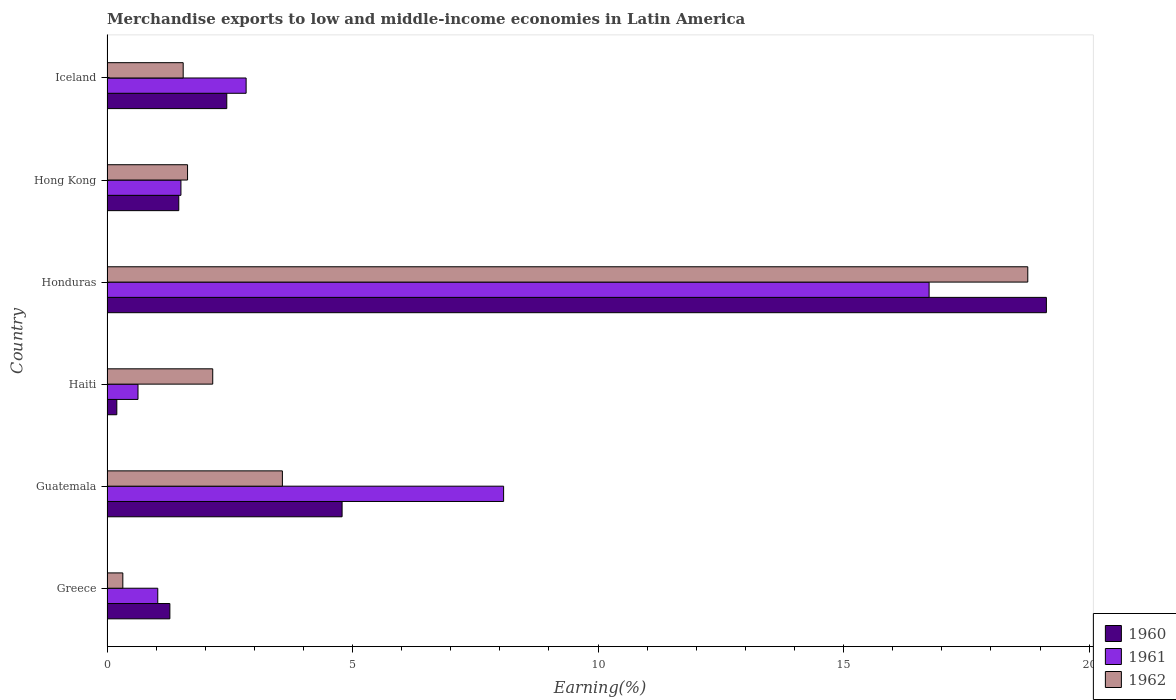How many bars are there on the 2nd tick from the top?
Offer a very short reply. 3. What is the label of the 2nd group of bars from the top?
Make the answer very short. Hong Kong. In how many cases, is the number of bars for a given country not equal to the number of legend labels?
Offer a very short reply. 0. What is the percentage of amount earned from merchandise exports in 1961 in Hong Kong?
Provide a succinct answer. 1.51. Across all countries, what is the maximum percentage of amount earned from merchandise exports in 1961?
Provide a succinct answer. 16.74. Across all countries, what is the minimum percentage of amount earned from merchandise exports in 1960?
Make the answer very short. 0.2. In which country was the percentage of amount earned from merchandise exports in 1960 maximum?
Provide a short and direct response. Honduras. In which country was the percentage of amount earned from merchandise exports in 1961 minimum?
Ensure brevity in your answer.  Haiti. What is the total percentage of amount earned from merchandise exports in 1960 in the graph?
Offer a very short reply. 29.3. What is the difference between the percentage of amount earned from merchandise exports in 1961 in Honduras and that in Iceland?
Give a very brief answer. 13.91. What is the difference between the percentage of amount earned from merchandise exports in 1962 in Iceland and the percentage of amount earned from merchandise exports in 1960 in Haiti?
Make the answer very short. 1.35. What is the average percentage of amount earned from merchandise exports in 1961 per country?
Ensure brevity in your answer.  5.14. What is the difference between the percentage of amount earned from merchandise exports in 1962 and percentage of amount earned from merchandise exports in 1960 in Iceland?
Make the answer very short. -0.89. What is the ratio of the percentage of amount earned from merchandise exports in 1962 in Greece to that in Haiti?
Your response must be concise. 0.15. What is the difference between the highest and the second highest percentage of amount earned from merchandise exports in 1960?
Provide a succinct answer. 14.34. What is the difference between the highest and the lowest percentage of amount earned from merchandise exports in 1962?
Offer a very short reply. 18.43. What does the 2nd bar from the top in Haiti represents?
Your response must be concise. 1961. Is it the case that in every country, the sum of the percentage of amount earned from merchandise exports in 1960 and percentage of amount earned from merchandise exports in 1961 is greater than the percentage of amount earned from merchandise exports in 1962?
Provide a succinct answer. No. Does the graph contain grids?
Provide a succinct answer. No. How many legend labels are there?
Give a very brief answer. 3. How are the legend labels stacked?
Your answer should be compact. Vertical. What is the title of the graph?
Provide a short and direct response. Merchandise exports to low and middle-income economies in Latin America. What is the label or title of the X-axis?
Keep it short and to the point. Earning(%). What is the label or title of the Y-axis?
Ensure brevity in your answer.  Country. What is the Earning(%) in 1960 in Greece?
Offer a very short reply. 1.28. What is the Earning(%) of 1961 in Greece?
Give a very brief answer. 1.03. What is the Earning(%) of 1962 in Greece?
Ensure brevity in your answer.  0.32. What is the Earning(%) in 1960 in Guatemala?
Give a very brief answer. 4.79. What is the Earning(%) of 1961 in Guatemala?
Your response must be concise. 8.08. What is the Earning(%) of 1962 in Guatemala?
Your answer should be compact. 3.57. What is the Earning(%) of 1960 in Haiti?
Offer a very short reply. 0.2. What is the Earning(%) in 1961 in Haiti?
Your answer should be very brief. 0.63. What is the Earning(%) in 1962 in Haiti?
Offer a very short reply. 2.15. What is the Earning(%) of 1960 in Honduras?
Provide a succinct answer. 19.13. What is the Earning(%) in 1961 in Honduras?
Offer a terse response. 16.74. What is the Earning(%) of 1962 in Honduras?
Your response must be concise. 18.75. What is the Earning(%) of 1960 in Hong Kong?
Ensure brevity in your answer.  1.46. What is the Earning(%) in 1961 in Hong Kong?
Your answer should be very brief. 1.51. What is the Earning(%) in 1962 in Hong Kong?
Offer a very short reply. 1.64. What is the Earning(%) in 1960 in Iceland?
Ensure brevity in your answer.  2.44. What is the Earning(%) of 1961 in Iceland?
Your answer should be compact. 2.83. What is the Earning(%) of 1962 in Iceland?
Give a very brief answer. 1.55. Across all countries, what is the maximum Earning(%) in 1960?
Make the answer very short. 19.13. Across all countries, what is the maximum Earning(%) of 1961?
Your response must be concise. 16.74. Across all countries, what is the maximum Earning(%) of 1962?
Your answer should be very brief. 18.75. Across all countries, what is the minimum Earning(%) of 1960?
Give a very brief answer. 0.2. Across all countries, what is the minimum Earning(%) in 1961?
Give a very brief answer. 0.63. Across all countries, what is the minimum Earning(%) in 1962?
Your answer should be compact. 0.32. What is the total Earning(%) of 1960 in the graph?
Your answer should be compact. 29.3. What is the total Earning(%) of 1961 in the graph?
Offer a very short reply. 30.82. What is the total Earning(%) of 1962 in the graph?
Provide a succinct answer. 27.99. What is the difference between the Earning(%) of 1960 in Greece and that in Guatemala?
Keep it short and to the point. -3.51. What is the difference between the Earning(%) in 1961 in Greece and that in Guatemala?
Give a very brief answer. -7.04. What is the difference between the Earning(%) of 1962 in Greece and that in Guatemala?
Provide a short and direct response. -3.25. What is the difference between the Earning(%) in 1960 in Greece and that in Haiti?
Offer a terse response. 1.08. What is the difference between the Earning(%) of 1961 in Greece and that in Haiti?
Ensure brevity in your answer.  0.4. What is the difference between the Earning(%) of 1962 in Greece and that in Haiti?
Keep it short and to the point. -1.83. What is the difference between the Earning(%) in 1960 in Greece and that in Honduras?
Offer a very short reply. -17.85. What is the difference between the Earning(%) of 1961 in Greece and that in Honduras?
Offer a terse response. -15.71. What is the difference between the Earning(%) of 1962 in Greece and that in Honduras?
Provide a succinct answer. -18.43. What is the difference between the Earning(%) in 1960 in Greece and that in Hong Kong?
Offer a very short reply. -0.18. What is the difference between the Earning(%) in 1961 in Greece and that in Hong Kong?
Ensure brevity in your answer.  -0.47. What is the difference between the Earning(%) in 1962 in Greece and that in Hong Kong?
Provide a succinct answer. -1.32. What is the difference between the Earning(%) in 1960 in Greece and that in Iceland?
Your response must be concise. -1.16. What is the difference between the Earning(%) in 1961 in Greece and that in Iceland?
Offer a very short reply. -1.8. What is the difference between the Earning(%) of 1962 in Greece and that in Iceland?
Keep it short and to the point. -1.23. What is the difference between the Earning(%) in 1960 in Guatemala and that in Haiti?
Your answer should be very brief. 4.59. What is the difference between the Earning(%) of 1961 in Guatemala and that in Haiti?
Provide a short and direct response. 7.45. What is the difference between the Earning(%) in 1962 in Guatemala and that in Haiti?
Your answer should be very brief. 1.42. What is the difference between the Earning(%) in 1960 in Guatemala and that in Honduras?
Your response must be concise. -14.34. What is the difference between the Earning(%) of 1961 in Guatemala and that in Honduras?
Your response must be concise. -8.66. What is the difference between the Earning(%) in 1962 in Guatemala and that in Honduras?
Keep it short and to the point. -15.18. What is the difference between the Earning(%) of 1960 in Guatemala and that in Hong Kong?
Your answer should be compact. 3.33. What is the difference between the Earning(%) of 1961 in Guatemala and that in Hong Kong?
Your answer should be very brief. 6.57. What is the difference between the Earning(%) in 1962 in Guatemala and that in Hong Kong?
Your answer should be very brief. 1.93. What is the difference between the Earning(%) of 1960 in Guatemala and that in Iceland?
Your answer should be compact. 2.35. What is the difference between the Earning(%) in 1961 in Guatemala and that in Iceland?
Offer a terse response. 5.24. What is the difference between the Earning(%) of 1962 in Guatemala and that in Iceland?
Your answer should be very brief. 2.02. What is the difference between the Earning(%) in 1960 in Haiti and that in Honduras?
Offer a very short reply. -18.93. What is the difference between the Earning(%) in 1961 in Haiti and that in Honduras?
Offer a terse response. -16.11. What is the difference between the Earning(%) of 1962 in Haiti and that in Honduras?
Offer a very short reply. -16.6. What is the difference between the Earning(%) of 1960 in Haiti and that in Hong Kong?
Ensure brevity in your answer.  -1.26. What is the difference between the Earning(%) in 1961 in Haiti and that in Hong Kong?
Offer a terse response. -0.87. What is the difference between the Earning(%) in 1962 in Haiti and that in Hong Kong?
Your answer should be very brief. 0.51. What is the difference between the Earning(%) of 1960 in Haiti and that in Iceland?
Make the answer very short. -2.24. What is the difference between the Earning(%) in 1961 in Haiti and that in Iceland?
Give a very brief answer. -2.2. What is the difference between the Earning(%) in 1962 in Haiti and that in Iceland?
Provide a succinct answer. 0.6. What is the difference between the Earning(%) in 1960 in Honduras and that in Hong Kong?
Your answer should be compact. 17.67. What is the difference between the Earning(%) of 1961 in Honduras and that in Hong Kong?
Your response must be concise. 15.24. What is the difference between the Earning(%) of 1962 in Honduras and that in Hong Kong?
Provide a short and direct response. 17.11. What is the difference between the Earning(%) of 1960 in Honduras and that in Iceland?
Your response must be concise. 16.69. What is the difference between the Earning(%) of 1961 in Honduras and that in Iceland?
Your response must be concise. 13.91. What is the difference between the Earning(%) in 1962 in Honduras and that in Iceland?
Make the answer very short. 17.2. What is the difference between the Earning(%) in 1960 in Hong Kong and that in Iceland?
Your response must be concise. -0.98. What is the difference between the Earning(%) of 1961 in Hong Kong and that in Iceland?
Offer a terse response. -1.33. What is the difference between the Earning(%) of 1962 in Hong Kong and that in Iceland?
Provide a succinct answer. 0.09. What is the difference between the Earning(%) in 1960 in Greece and the Earning(%) in 1961 in Guatemala?
Your answer should be compact. -6.8. What is the difference between the Earning(%) of 1960 in Greece and the Earning(%) of 1962 in Guatemala?
Give a very brief answer. -2.29. What is the difference between the Earning(%) of 1961 in Greece and the Earning(%) of 1962 in Guatemala?
Provide a succinct answer. -2.54. What is the difference between the Earning(%) of 1960 in Greece and the Earning(%) of 1961 in Haiti?
Give a very brief answer. 0.65. What is the difference between the Earning(%) in 1960 in Greece and the Earning(%) in 1962 in Haiti?
Provide a succinct answer. -0.87. What is the difference between the Earning(%) in 1961 in Greece and the Earning(%) in 1962 in Haiti?
Your answer should be compact. -1.12. What is the difference between the Earning(%) in 1960 in Greece and the Earning(%) in 1961 in Honduras?
Your response must be concise. -15.46. What is the difference between the Earning(%) of 1960 in Greece and the Earning(%) of 1962 in Honduras?
Your answer should be compact. -17.47. What is the difference between the Earning(%) in 1961 in Greece and the Earning(%) in 1962 in Honduras?
Your response must be concise. -17.72. What is the difference between the Earning(%) of 1960 in Greece and the Earning(%) of 1961 in Hong Kong?
Your response must be concise. -0.23. What is the difference between the Earning(%) in 1960 in Greece and the Earning(%) in 1962 in Hong Kong?
Your answer should be very brief. -0.36. What is the difference between the Earning(%) in 1961 in Greece and the Earning(%) in 1962 in Hong Kong?
Your response must be concise. -0.61. What is the difference between the Earning(%) in 1960 in Greece and the Earning(%) in 1961 in Iceland?
Your response must be concise. -1.55. What is the difference between the Earning(%) in 1960 in Greece and the Earning(%) in 1962 in Iceland?
Keep it short and to the point. -0.27. What is the difference between the Earning(%) in 1961 in Greece and the Earning(%) in 1962 in Iceland?
Ensure brevity in your answer.  -0.52. What is the difference between the Earning(%) in 1960 in Guatemala and the Earning(%) in 1961 in Haiti?
Your answer should be compact. 4.16. What is the difference between the Earning(%) of 1960 in Guatemala and the Earning(%) of 1962 in Haiti?
Provide a short and direct response. 2.63. What is the difference between the Earning(%) in 1961 in Guatemala and the Earning(%) in 1962 in Haiti?
Your answer should be very brief. 5.92. What is the difference between the Earning(%) in 1960 in Guatemala and the Earning(%) in 1961 in Honduras?
Keep it short and to the point. -11.95. What is the difference between the Earning(%) in 1960 in Guatemala and the Earning(%) in 1962 in Honduras?
Your response must be concise. -13.96. What is the difference between the Earning(%) of 1961 in Guatemala and the Earning(%) of 1962 in Honduras?
Ensure brevity in your answer.  -10.67. What is the difference between the Earning(%) of 1960 in Guatemala and the Earning(%) of 1961 in Hong Kong?
Ensure brevity in your answer.  3.28. What is the difference between the Earning(%) of 1960 in Guatemala and the Earning(%) of 1962 in Hong Kong?
Offer a very short reply. 3.15. What is the difference between the Earning(%) in 1961 in Guatemala and the Earning(%) in 1962 in Hong Kong?
Your answer should be very brief. 6.44. What is the difference between the Earning(%) of 1960 in Guatemala and the Earning(%) of 1961 in Iceland?
Keep it short and to the point. 1.95. What is the difference between the Earning(%) in 1960 in Guatemala and the Earning(%) in 1962 in Iceland?
Provide a succinct answer. 3.24. What is the difference between the Earning(%) of 1961 in Guatemala and the Earning(%) of 1962 in Iceland?
Keep it short and to the point. 6.52. What is the difference between the Earning(%) of 1960 in Haiti and the Earning(%) of 1961 in Honduras?
Ensure brevity in your answer.  -16.54. What is the difference between the Earning(%) in 1960 in Haiti and the Earning(%) in 1962 in Honduras?
Make the answer very short. -18.55. What is the difference between the Earning(%) in 1961 in Haiti and the Earning(%) in 1962 in Honduras?
Give a very brief answer. -18.12. What is the difference between the Earning(%) in 1960 in Haiti and the Earning(%) in 1961 in Hong Kong?
Offer a very short reply. -1.31. What is the difference between the Earning(%) in 1960 in Haiti and the Earning(%) in 1962 in Hong Kong?
Your response must be concise. -1.44. What is the difference between the Earning(%) in 1961 in Haiti and the Earning(%) in 1962 in Hong Kong?
Your response must be concise. -1.01. What is the difference between the Earning(%) of 1960 in Haiti and the Earning(%) of 1961 in Iceland?
Ensure brevity in your answer.  -2.63. What is the difference between the Earning(%) of 1960 in Haiti and the Earning(%) of 1962 in Iceland?
Your answer should be very brief. -1.35. What is the difference between the Earning(%) in 1961 in Haiti and the Earning(%) in 1962 in Iceland?
Ensure brevity in your answer.  -0.92. What is the difference between the Earning(%) in 1960 in Honduras and the Earning(%) in 1961 in Hong Kong?
Offer a very short reply. 17.62. What is the difference between the Earning(%) in 1960 in Honduras and the Earning(%) in 1962 in Hong Kong?
Ensure brevity in your answer.  17.49. What is the difference between the Earning(%) of 1961 in Honduras and the Earning(%) of 1962 in Hong Kong?
Provide a succinct answer. 15.1. What is the difference between the Earning(%) in 1960 in Honduras and the Earning(%) in 1961 in Iceland?
Give a very brief answer. 16.3. What is the difference between the Earning(%) in 1960 in Honduras and the Earning(%) in 1962 in Iceland?
Provide a succinct answer. 17.58. What is the difference between the Earning(%) of 1961 in Honduras and the Earning(%) of 1962 in Iceland?
Provide a short and direct response. 15.19. What is the difference between the Earning(%) of 1960 in Hong Kong and the Earning(%) of 1961 in Iceland?
Your answer should be compact. -1.37. What is the difference between the Earning(%) in 1960 in Hong Kong and the Earning(%) in 1962 in Iceland?
Offer a terse response. -0.09. What is the difference between the Earning(%) of 1961 in Hong Kong and the Earning(%) of 1962 in Iceland?
Your response must be concise. -0.05. What is the average Earning(%) in 1960 per country?
Offer a very short reply. 4.88. What is the average Earning(%) in 1961 per country?
Your answer should be very brief. 5.14. What is the average Earning(%) of 1962 per country?
Ensure brevity in your answer.  4.66. What is the difference between the Earning(%) in 1960 and Earning(%) in 1961 in Greece?
Keep it short and to the point. 0.25. What is the difference between the Earning(%) of 1960 and Earning(%) of 1962 in Greece?
Provide a short and direct response. 0.96. What is the difference between the Earning(%) of 1961 and Earning(%) of 1962 in Greece?
Your answer should be compact. 0.71. What is the difference between the Earning(%) of 1960 and Earning(%) of 1961 in Guatemala?
Ensure brevity in your answer.  -3.29. What is the difference between the Earning(%) of 1960 and Earning(%) of 1962 in Guatemala?
Your response must be concise. 1.22. What is the difference between the Earning(%) in 1961 and Earning(%) in 1962 in Guatemala?
Your answer should be very brief. 4.5. What is the difference between the Earning(%) in 1960 and Earning(%) in 1961 in Haiti?
Your answer should be compact. -0.43. What is the difference between the Earning(%) of 1960 and Earning(%) of 1962 in Haiti?
Ensure brevity in your answer.  -1.95. What is the difference between the Earning(%) in 1961 and Earning(%) in 1962 in Haiti?
Give a very brief answer. -1.52. What is the difference between the Earning(%) of 1960 and Earning(%) of 1961 in Honduras?
Give a very brief answer. 2.39. What is the difference between the Earning(%) of 1960 and Earning(%) of 1962 in Honduras?
Provide a succinct answer. 0.38. What is the difference between the Earning(%) of 1961 and Earning(%) of 1962 in Honduras?
Give a very brief answer. -2.01. What is the difference between the Earning(%) of 1960 and Earning(%) of 1961 in Hong Kong?
Make the answer very short. -0.04. What is the difference between the Earning(%) in 1960 and Earning(%) in 1962 in Hong Kong?
Ensure brevity in your answer.  -0.18. What is the difference between the Earning(%) in 1961 and Earning(%) in 1962 in Hong Kong?
Make the answer very short. -0.13. What is the difference between the Earning(%) in 1960 and Earning(%) in 1961 in Iceland?
Offer a very short reply. -0.39. What is the difference between the Earning(%) of 1960 and Earning(%) of 1962 in Iceland?
Your answer should be very brief. 0.89. What is the difference between the Earning(%) of 1961 and Earning(%) of 1962 in Iceland?
Your answer should be very brief. 1.28. What is the ratio of the Earning(%) of 1960 in Greece to that in Guatemala?
Ensure brevity in your answer.  0.27. What is the ratio of the Earning(%) of 1961 in Greece to that in Guatemala?
Your response must be concise. 0.13. What is the ratio of the Earning(%) in 1962 in Greece to that in Guatemala?
Your answer should be compact. 0.09. What is the ratio of the Earning(%) in 1960 in Greece to that in Haiti?
Ensure brevity in your answer.  6.41. What is the ratio of the Earning(%) of 1961 in Greece to that in Haiti?
Offer a very short reply. 1.64. What is the ratio of the Earning(%) of 1962 in Greece to that in Haiti?
Give a very brief answer. 0.15. What is the ratio of the Earning(%) in 1960 in Greece to that in Honduras?
Give a very brief answer. 0.07. What is the ratio of the Earning(%) in 1961 in Greece to that in Honduras?
Your answer should be very brief. 0.06. What is the ratio of the Earning(%) in 1962 in Greece to that in Honduras?
Provide a short and direct response. 0.02. What is the ratio of the Earning(%) of 1960 in Greece to that in Hong Kong?
Provide a succinct answer. 0.88. What is the ratio of the Earning(%) of 1961 in Greece to that in Hong Kong?
Offer a terse response. 0.69. What is the ratio of the Earning(%) in 1962 in Greece to that in Hong Kong?
Provide a succinct answer. 0.2. What is the ratio of the Earning(%) in 1960 in Greece to that in Iceland?
Give a very brief answer. 0.52. What is the ratio of the Earning(%) in 1961 in Greece to that in Iceland?
Your answer should be very brief. 0.36. What is the ratio of the Earning(%) of 1962 in Greece to that in Iceland?
Keep it short and to the point. 0.21. What is the ratio of the Earning(%) of 1960 in Guatemala to that in Haiti?
Offer a very short reply. 23.97. What is the ratio of the Earning(%) in 1961 in Guatemala to that in Haiti?
Provide a succinct answer. 12.79. What is the ratio of the Earning(%) in 1962 in Guatemala to that in Haiti?
Provide a succinct answer. 1.66. What is the ratio of the Earning(%) of 1960 in Guatemala to that in Honduras?
Offer a terse response. 0.25. What is the ratio of the Earning(%) in 1961 in Guatemala to that in Honduras?
Make the answer very short. 0.48. What is the ratio of the Earning(%) in 1962 in Guatemala to that in Honduras?
Give a very brief answer. 0.19. What is the ratio of the Earning(%) of 1960 in Guatemala to that in Hong Kong?
Provide a succinct answer. 3.28. What is the ratio of the Earning(%) of 1961 in Guatemala to that in Hong Kong?
Give a very brief answer. 5.36. What is the ratio of the Earning(%) of 1962 in Guatemala to that in Hong Kong?
Offer a terse response. 2.18. What is the ratio of the Earning(%) of 1960 in Guatemala to that in Iceland?
Keep it short and to the point. 1.96. What is the ratio of the Earning(%) in 1961 in Guatemala to that in Iceland?
Offer a very short reply. 2.85. What is the ratio of the Earning(%) in 1962 in Guatemala to that in Iceland?
Offer a terse response. 2.3. What is the ratio of the Earning(%) of 1960 in Haiti to that in Honduras?
Your answer should be compact. 0.01. What is the ratio of the Earning(%) in 1961 in Haiti to that in Honduras?
Provide a short and direct response. 0.04. What is the ratio of the Earning(%) in 1962 in Haiti to that in Honduras?
Make the answer very short. 0.11. What is the ratio of the Earning(%) in 1960 in Haiti to that in Hong Kong?
Give a very brief answer. 0.14. What is the ratio of the Earning(%) in 1961 in Haiti to that in Hong Kong?
Provide a succinct answer. 0.42. What is the ratio of the Earning(%) in 1962 in Haiti to that in Hong Kong?
Ensure brevity in your answer.  1.31. What is the ratio of the Earning(%) of 1960 in Haiti to that in Iceland?
Provide a succinct answer. 0.08. What is the ratio of the Earning(%) in 1961 in Haiti to that in Iceland?
Your answer should be very brief. 0.22. What is the ratio of the Earning(%) in 1962 in Haiti to that in Iceland?
Keep it short and to the point. 1.39. What is the ratio of the Earning(%) in 1960 in Honduras to that in Hong Kong?
Offer a very short reply. 13.09. What is the ratio of the Earning(%) of 1961 in Honduras to that in Hong Kong?
Provide a succinct answer. 11.12. What is the ratio of the Earning(%) in 1962 in Honduras to that in Hong Kong?
Offer a terse response. 11.43. What is the ratio of the Earning(%) of 1960 in Honduras to that in Iceland?
Ensure brevity in your answer.  7.84. What is the ratio of the Earning(%) in 1961 in Honduras to that in Iceland?
Ensure brevity in your answer.  5.91. What is the ratio of the Earning(%) of 1962 in Honduras to that in Iceland?
Make the answer very short. 12.09. What is the ratio of the Earning(%) of 1960 in Hong Kong to that in Iceland?
Your answer should be very brief. 0.6. What is the ratio of the Earning(%) in 1961 in Hong Kong to that in Iceland?
Your answer should be compact. 0.53. What is the ratio of the Earning(%) in 1962 in Hong Kong to that in Iceland?
Make the answer very short. 1.06. What is the difference between the highest and the second highest Earning(%) of 1960?
Ensure brevity in your answer.  14.34. What is the difference between the highest and the second highest Earning(%) of 1961?
Keep it short and to the point. 8.66. What is the difference between the highest and the second highest Earning(%) in 1962?
Keep it short and to the point. 15.18. What is the difference between the highest and the lowest Earning(%) of 1960?
Your answer should be compact. 18.93. What is the difference between the highest and the lowest Earning(%) of 1961?
Your answer should be very brief. 16.11. What is the difference between the highest and the lowest Earning(%) of 1962?
Make the answer very short. 18.43. 